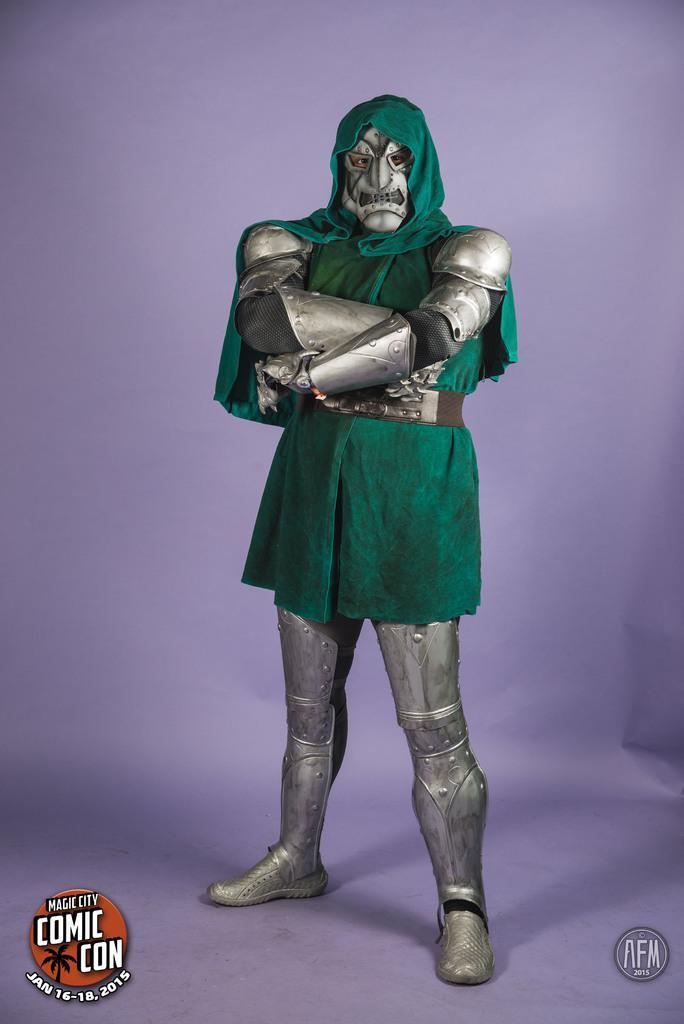Please provide a concise description of this image. In this picture there is a man who is wearing armour and green cloth. On the bottom left corner there is a watermark. In the back we can see purple color wall. 